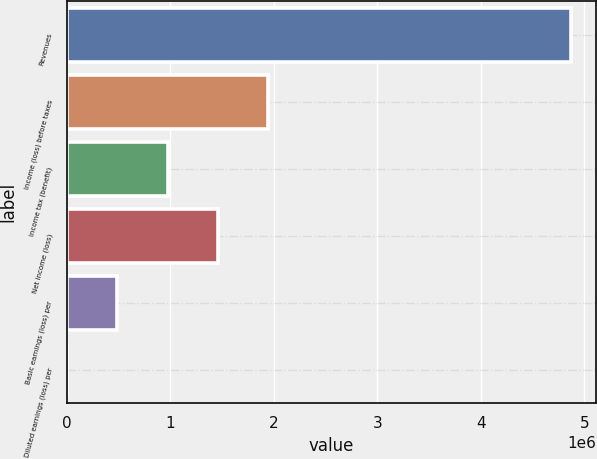<chart> <loc_0><loc_0><loc_500><loc_500><bar_chart><fcel>Revenues<fcel>Income (loss) before taxes<fcel>Income tax (benefit)<fcel>Net income (loss)<fcel>Basic earnings (loss) per<fcel>Diluted earnings (loss) per<nl><fcel>4.8728e+06<fcel>1.94912e+06<fcel>974561<fcel>1.46184e+06<fcel>487281<fcel>1.47<nl></chart> 